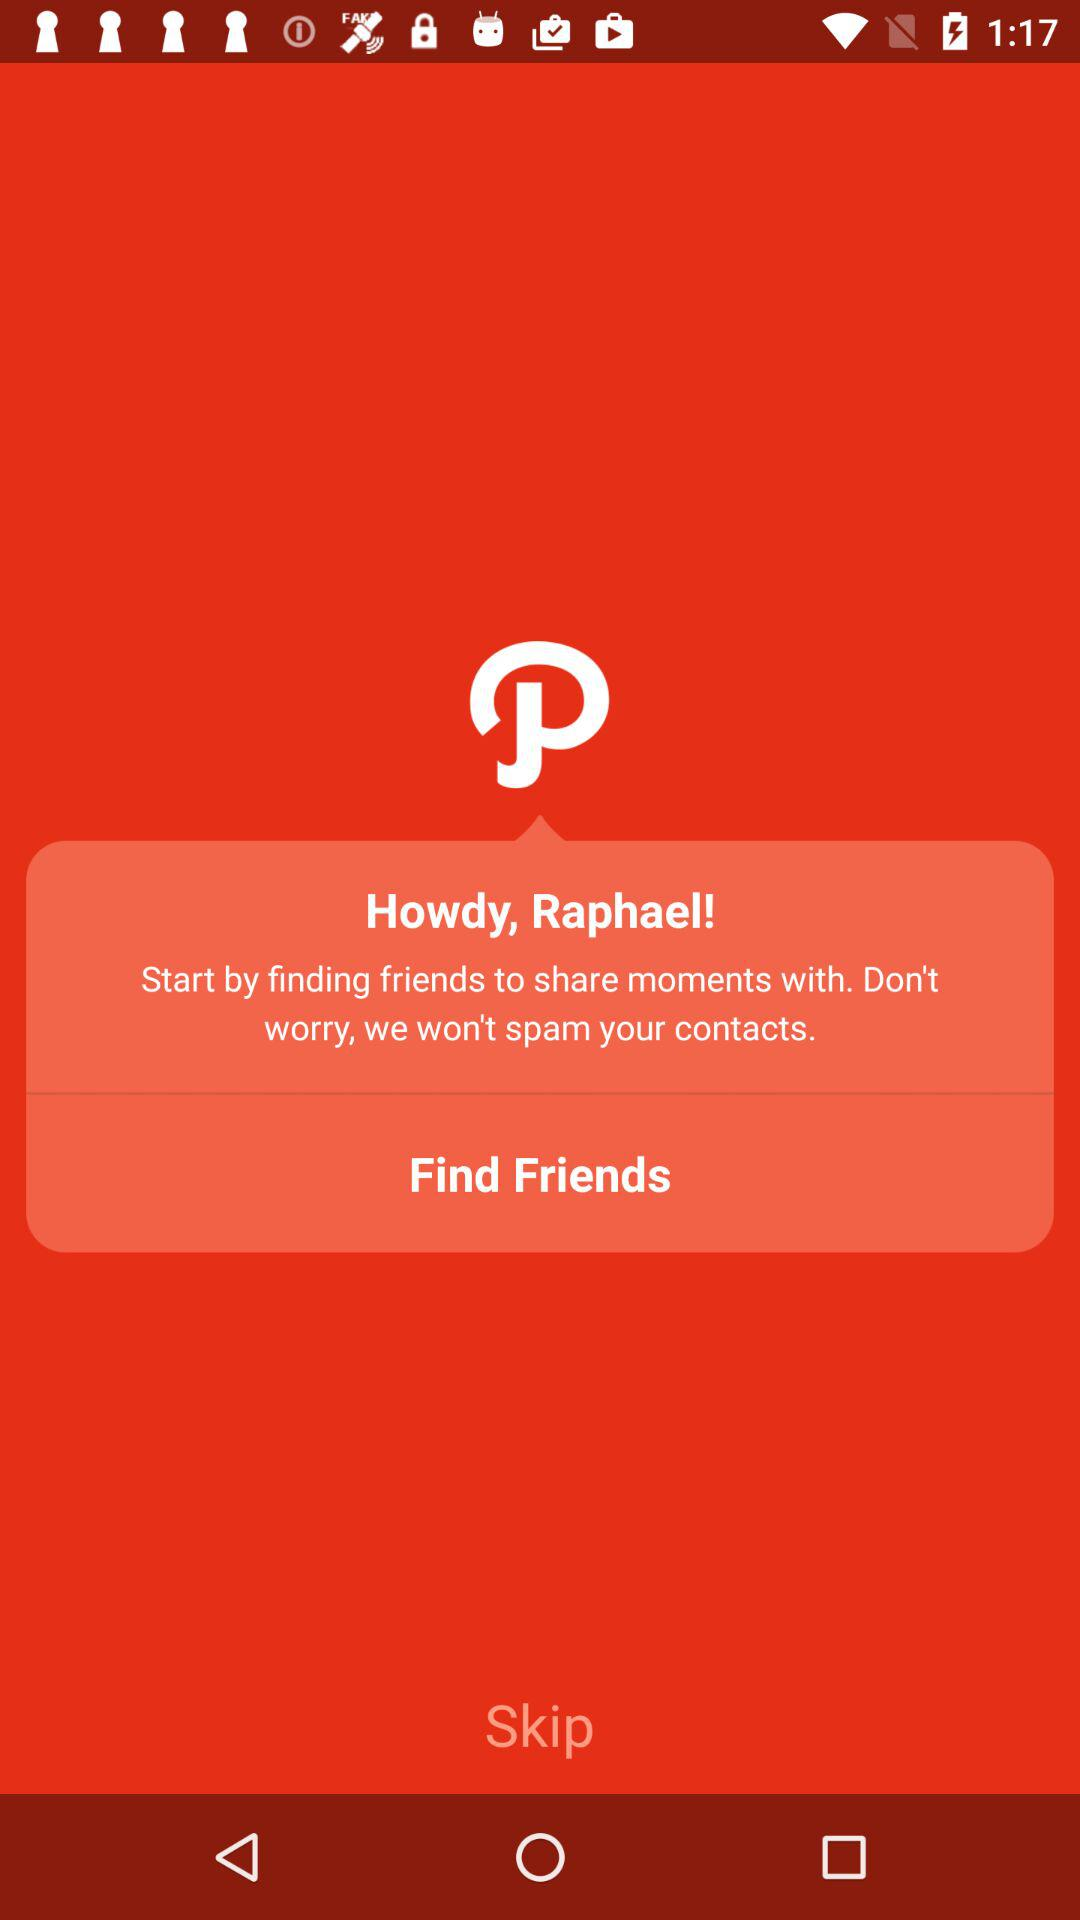What is the user name? The user name is Raphael. 